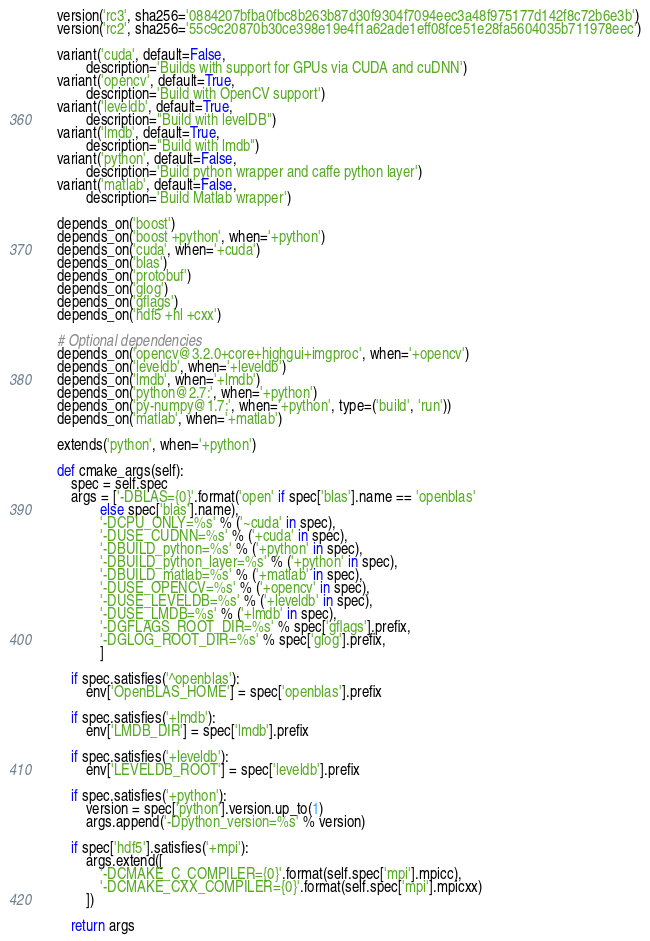Convert code to text. <code><loc_0><loc_0><loc_500><loc_500><_Python_>    version('rc3', sha256='0884207bfba0fbc8b263b87d30f9304f7094eec3a48f975177d142f8c72b6e3b')
    version('rc2', sha256='55c9c20870b30ce398e19e4f1a62ade1eff08fce51e28fa5604035b711978eec')

    variant('cuda', default=False,
            description='Builds with support for GPUs via CUDA and cuDNN')
    variant('opencv', default=True,
            description='Build with OpenCV support')
    variant('leveldb', default=True,
            description="Build with levelDB")
    variant('lmdb', default=True,
            description="Build with lmdb")
    variant('python', default=False,
            description='Build python wrapper and caffe python layer')
    variant('matlab', default=False,
            description='Build Matlab wrapper')

    depends_on('boost')
    depends_on('boost +python', when='+python')
    depends_on('cuda', when='+cuda')
    depends_on('blas')
    depends_on('protobuf')
    depends_on('glog')
    depends_on('gflags')
    depends_on('hdf5 +hl +cxx')

    # Optional dependencies
    depends_on('opencv@3.2.0+core+highgui+imgproc', when='+opencv')
    depends_on('leveldb', when='+leveldb')
    depends_on('lmdb', when='+lmdb')
    depends_on('python@2.7:', when='+python')
    depends_on('py-numpy@1.7:', when='+python', type=('build', 'run'))
    depends_on('matlab', when='+matlab')

    extends('python', when='+python')

    def cmake_args(self):
        spec = self.spec
        args = ['-DBLAS={0}'.format('open' if spec['blas'].name == 'openblas'
                else spec['blas'].name),
                '-DCPU_ONLY=%s' % ('~cuda' in spec),
                '-DUSE_CUDNN=%s' % ('+cuda' in spec),
                '-DBUILD_python=%s' % ('+python' in spec),
                '-DBUILD_python_layer=%s' % ('+python' in spec),
                '-DBUILD_matlab=%s' % ('+matlab' in spec),
                '-DUSE_OPENCV=%s' % ('+opencv' in spec),
                '-DUSE_LEVELDB=%s' % ('+leveldb' in spec),
                '-DUSE_LMDB=%s' % ('+lmdb' in spec),
                '-DGFLAGS_ROOT_DIR=%s' % spec['gflags'].prefix,
                '-DGLOG_ROOT_DIR=%s' % spec['glog'].prefix,
                ]

        if spec.satisfies('^openblas'):
            env['OpenBLAS_HOME'] = spec['openblas'].prefix

        if spec.satisfies('+lmdb'):
            env['LMDB_DIR'] = spec['lmdb'].prefix

        if spec.satisfies('+leveldb'):
            env['LEVELDB_ROOT'] = spec['leveldb'].prefix

        if spec.satisfies('+python'):
            version = spec['python'].version.up_to(1)
            args.append('-Dpython_version=%s' % version)

        if spec['hdf5'].satisfies('+mpi'):
            args.extend([
                '-DCMAKE_C_COMPILER={0}'.format(self.spec['mpi'].mpicc),
                '-DCMAKE_CXX_COMPILER={0}'.format(self.spec['mpi'].mpicxx)
            ])

        return args
</code> 